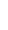Convert code to text. <code><loc_0><loc_0><loc_500><loc_500><_Nim_>






































</code> 